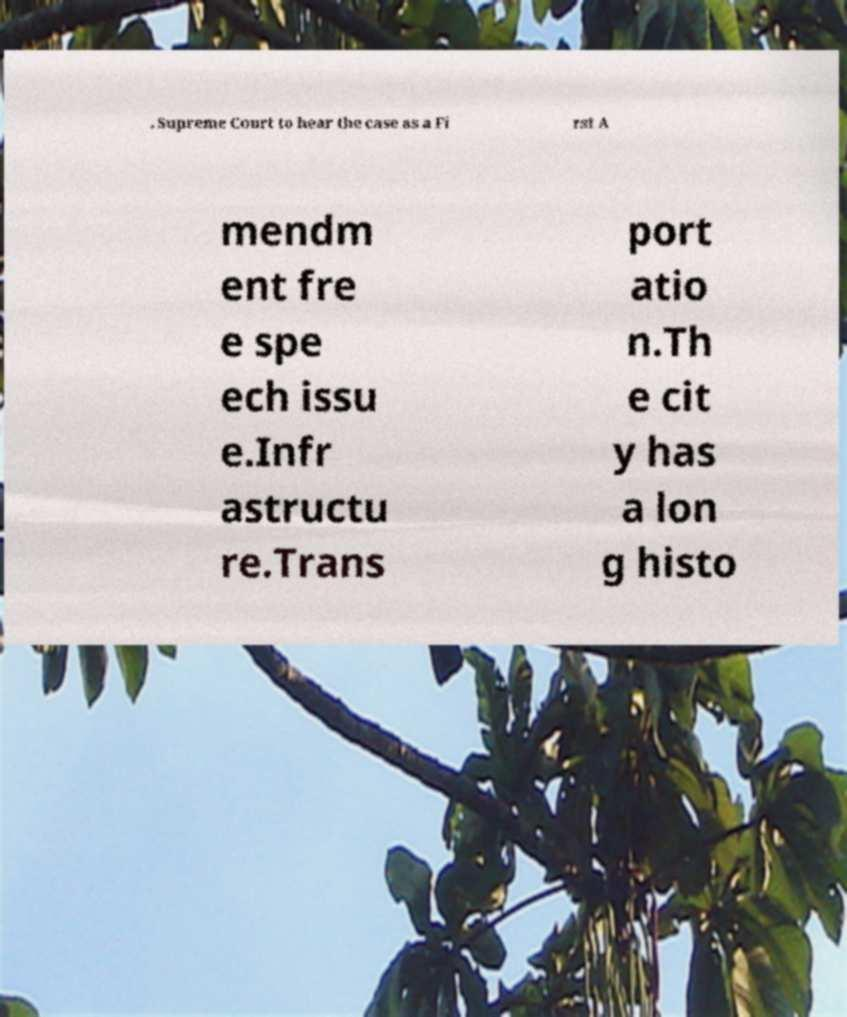Please identify and transcribe the text found in this image. . Supreme Court to hear the case as a Fi rst A mendm ent fre e spe ech issu e.Infr astructu re.Trans port atio n.Th e cit y has a lon g histo 